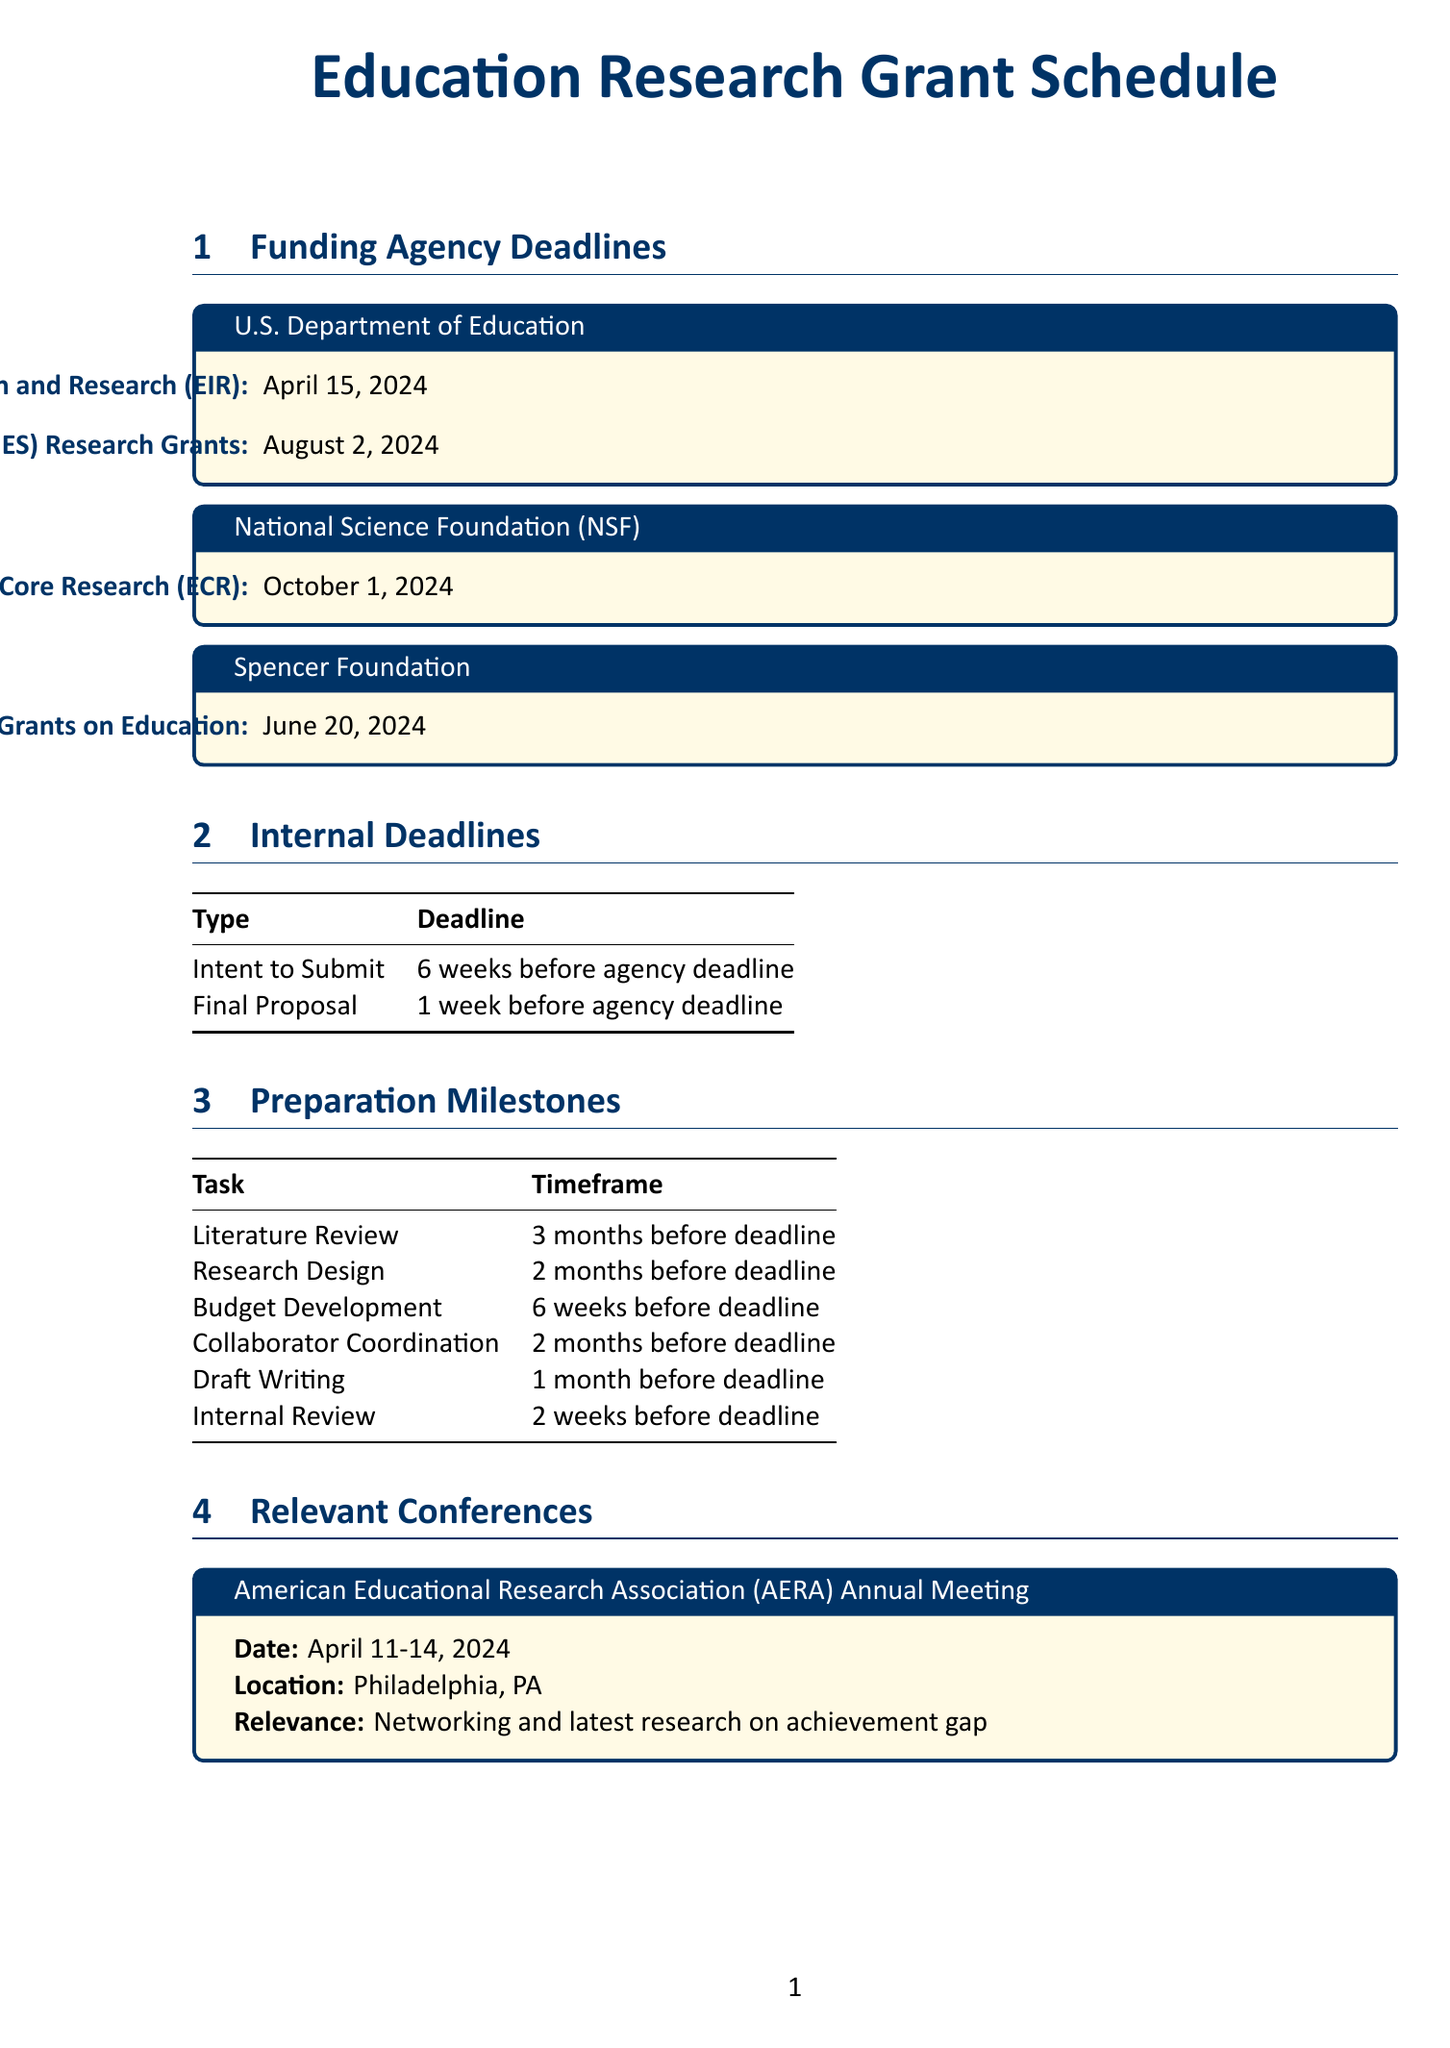What is the deadline for the EIR program? The deadline for the Education Innovation and Research (EIR) program is listed in the document as April 15, 2024.
Answer: April 15, 2024 What is the final proposal deadline for the Spencer Foundation? The final proposal for the Spencer Foundation must be submitted one week before the agency deadline, which is June 20, 2024.
Answer: June 13, 2024 How many weeks before the deadline is the intent to submit due? The document specifies the intent to submit is due 6 weeks before the agency deadline.
Answer: 6 weeks What is a relevant conference date in March 2024? The document lists the Association for Education Finance and Policy (AEFP) Annual Conference as occurring on March 21-23, 2024.
Answer: March 21-23, 2024 Which agency focuses on STEM education research? The National Science Foundation (NSF) focuses on STEM education research as indicated in the document.
Answer: National Science Foundation (NSF) What task must be completed 2 months before the deadline? The document states that the Research Design task needs to be completed 2 months before the deadline.
Answer: Research Design What is the focus of the IES Research Grants? The document mentions that the Institute of Education Sciences (IES) Research Grants focus on education research, including achievement gap studies.
Answer: Achievement gap studies What is the location of the AERA Annual Meeting? The document specifies that the American Educational Research Association (AERA) Annual Meeting will be held in Philadelphia, PA.
Answer: Philadelphia, PA 